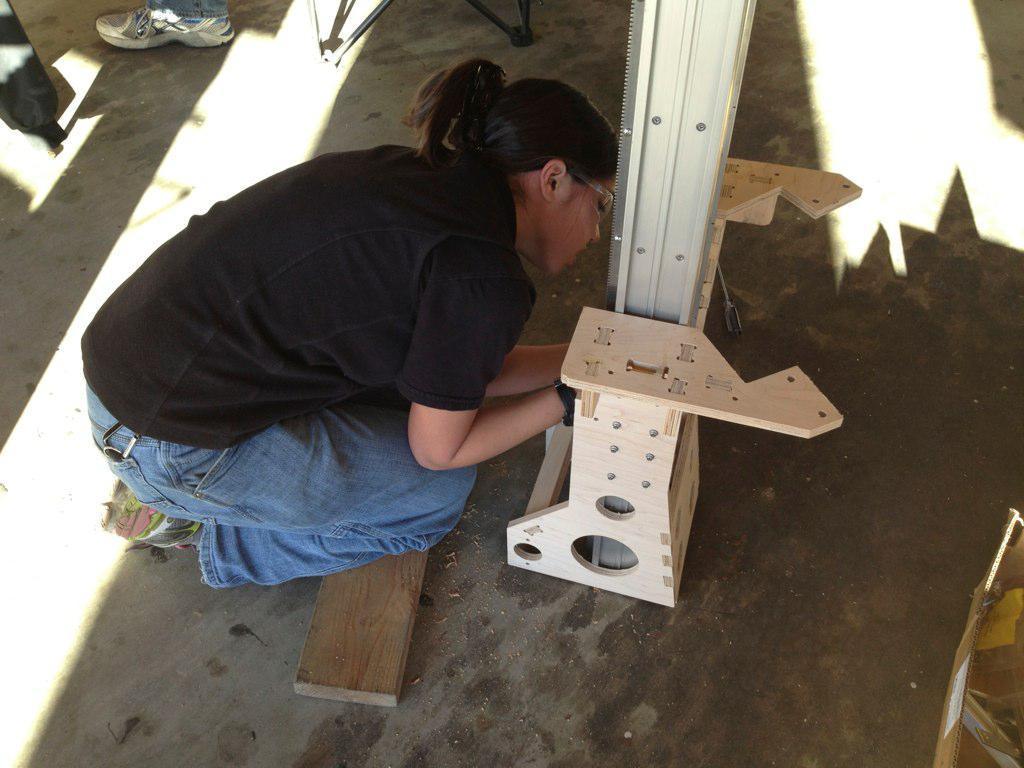Describe this image in one or two sentences. In the center of the image we can see one woman holding some object. In the background we can see one pole,shoe,wooden objects and a few other objects. 